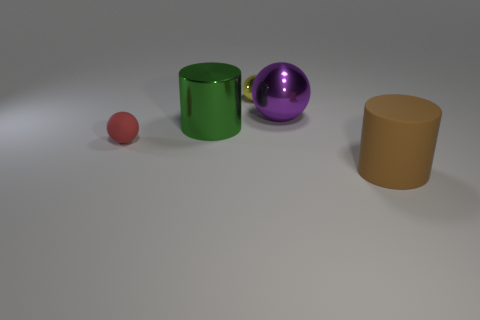Add 3 green cylinders. How many objects exist? 8 Subtract all cylinders. How many objects are left? 3 Add 1 large blocks. How many large blocks exist? 1 Subtract 0 brown balls. How many objects are left? 5 Subtract all large yellow cylinders. Subtract all big purple shiny things. How many objects are left? 4 Add 4 small red rubber objects. How many small red rubber objects are left? 5 